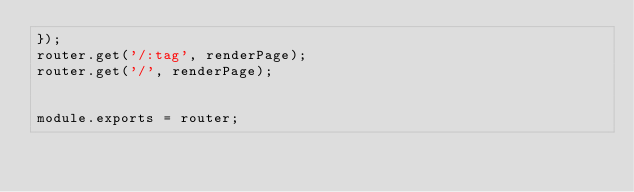Convert code to text. <code><loc_0><loc_0><loc_500><loc_500><_JavaScript_>});
router.get('/:tag', renderPage);
router.get('/', renderPage);


module.exports = router;</code> 